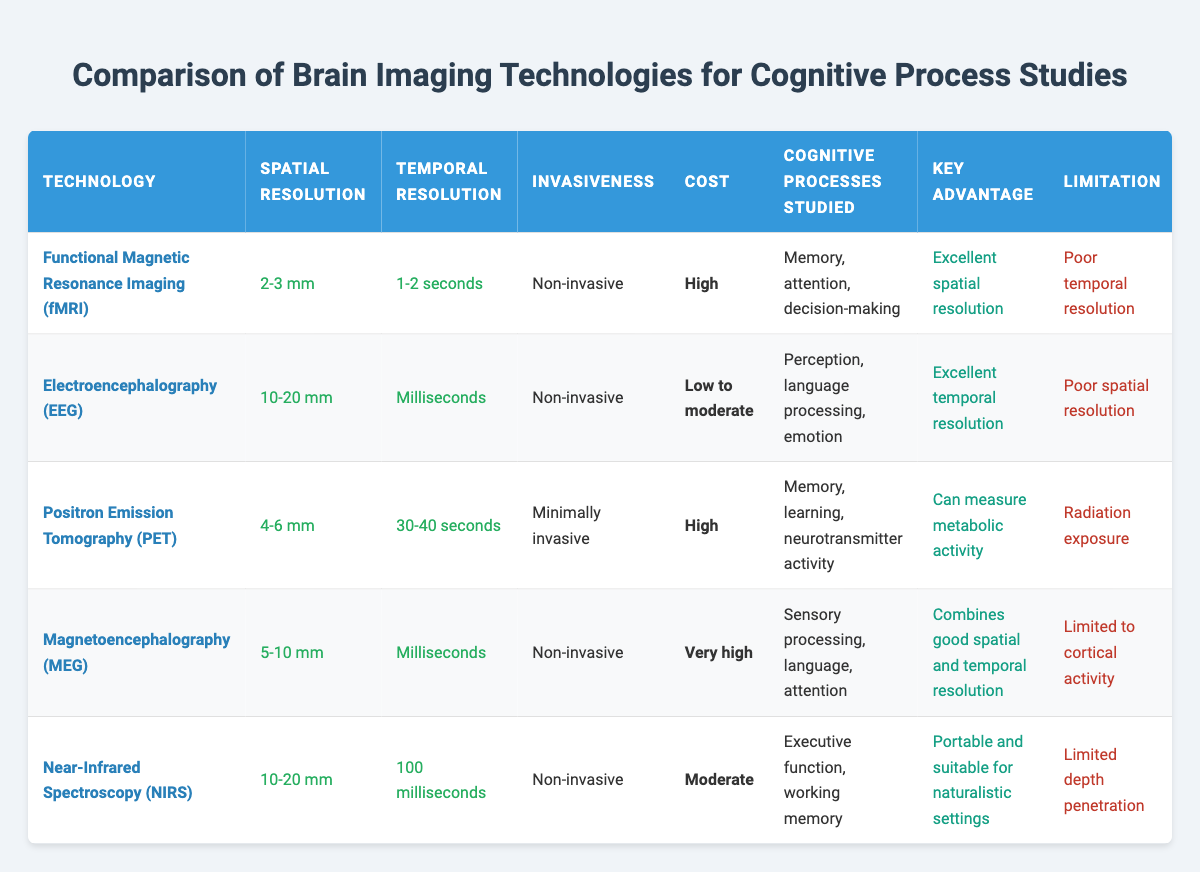What is the spatial resolution of fMRI? The spatial resolution for Functional Magnetic Resonance Imaging (fMRI) is listed in the table as 2-3 mm.
Answer: 2-3 mm Which technology has the best temporal resolution? The table indicates that Electroencephalography (EEG) has a temporal resolution of milliseconds, which is better than all the other technologies listed.
Answer: EEG True or False: PET imaging is non-invasive. According to the table, Positron Emission Tomography (PET) is categorized as minimally invasive, so the statement is false.
Answer: False What are the cognitive processes studied using Near-Infrared Spectroscopy (NIRS)? The table shows that Near-Infrared Spectroscopy (NIRS) is used to study executive function and working memory.
Answer: Executive function, working memory Which technology is described as having a "poor spatial resolution"? By examining the table, we find that Electroencephalography (EEG) has a poor spatial resolution, as indicated in the key advantage section.
Answer: EEG If we consider only non-invasive technologies, which one has the highest cost? The non-invasive technologies listed are fMRI, EEG, MEG, and NIRS. Comparing their costs, fMRI and MEG are high and very high, respectively. Thus, MEG has the highest cost among non-invasive technologies.
Answer: MEG What is the key advantage of using Magnetoencephalography (MEG)? The table states that the key advantage of Magnetoencephalography (MEG) is that it combines good spatial and temporal resolution, making it effective for many studies.
Answer: Combines good spatial and temporal resolution How many cognitive processes related to PET imaging are listed in the table? The table specifies three cognitive processes related to PET imaging: memory, learning, and neurotransmitter activity. The count of processes is three.
Answer: 3 Which technology can measure metabolic activity? The table clearly states that Positron Emission Tomography (PET) can measure metabolic activity, as noted in the key advantage section.
Answer: PET What is the temporal resolution difference between EEG and PET? The temporal resolution for EEG is in milliseconds, while for PET it is 30-40 seconds. The difference is calculated as 30 seconds (or about 29.5 seconds in a direct comparison of metrics).
Answer: 29 seconds 